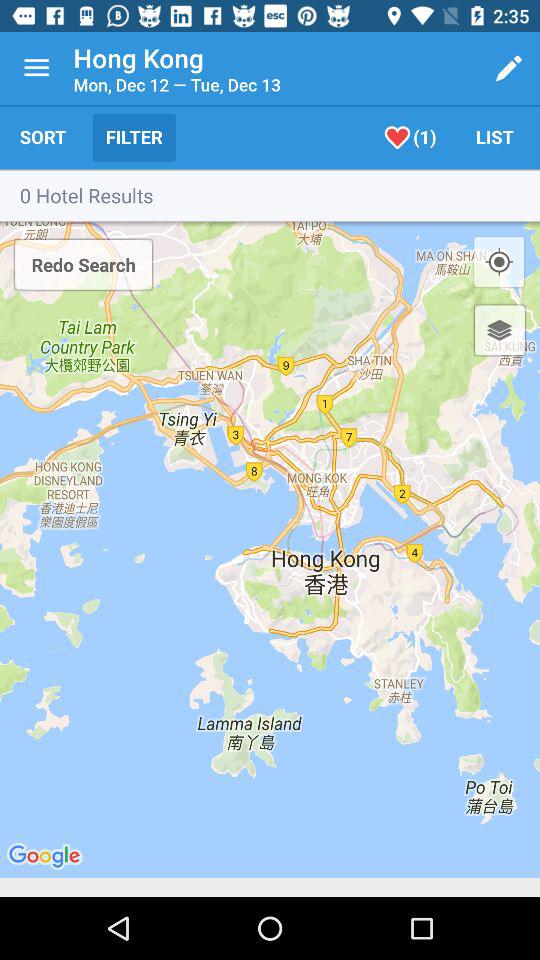How many hotel results are found on the map? There are 0 hotel results found on the map. 